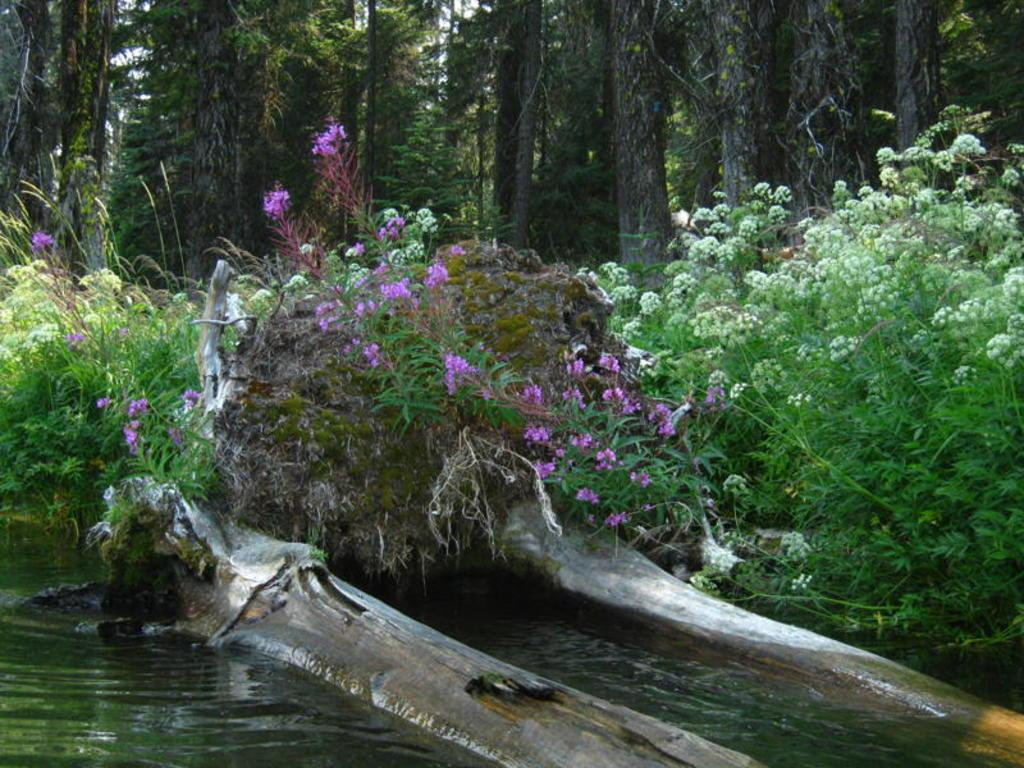What is the main subject of the image? The main subject of the image is water with tree trunks at the bottom. What can be seen behind the water in the image? There are plants with leaves and flowers behind the water. What is visible in the background of the image? There are trees in the background of the image. Can you tell me how many cows are grazing near the water in the image? There are no cows present in the image; it features water with tree trunks and plants with leaves and flowers. What type of beetle can be seen crawling on the tree trunks in the image? There are no beetles visible on the tree trunks in the image. 